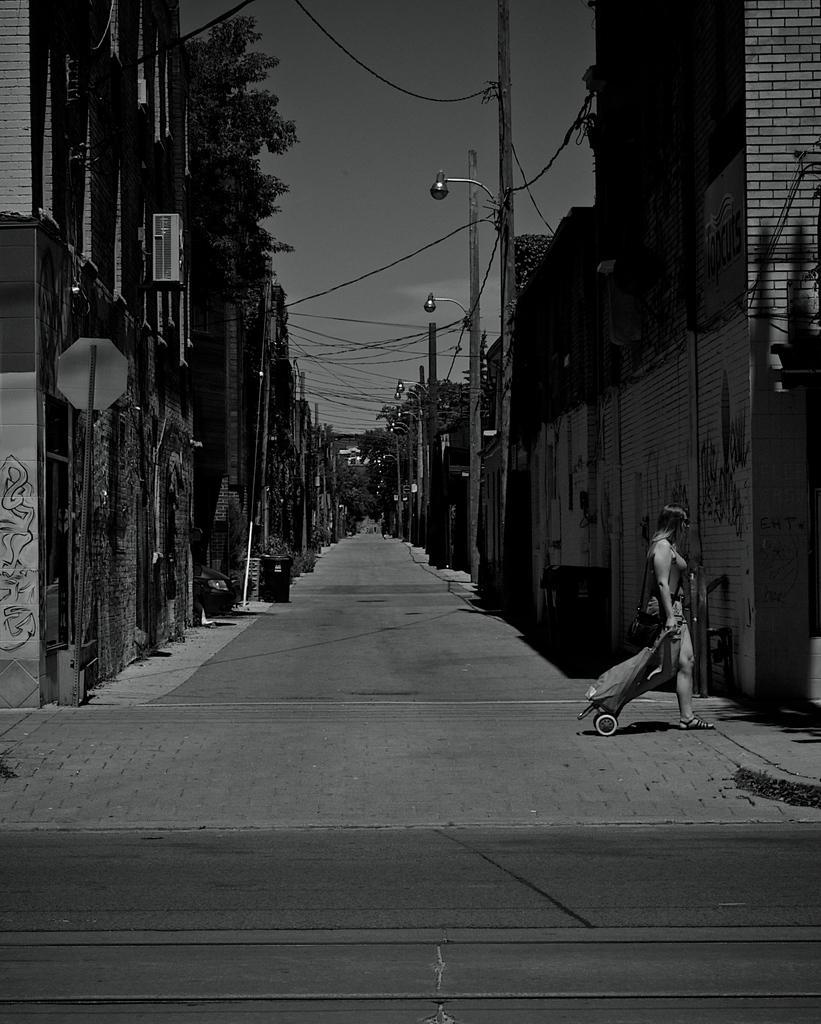How would you summarize this image in a sentence or two? In this image there is a empty road where a lady is walking along with trolley, beside that there are buildings, electric poles and trees. 